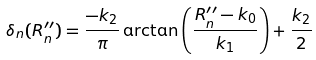Convert formula to latex. <formula><loc_0><loc_0><loc_500><loc_500>\delta _ { n } ( R ^ { \prime \prime } _ { n } ) = \frac { - k _ { 2 } } { \pi } \arctan \left ( \frac { R ^ { \prime \prime } _ { n } - k _ { 0 } } { k _ { 1 } } \right ) + \frac { k _ { 2 } } { 2 }</formula> 